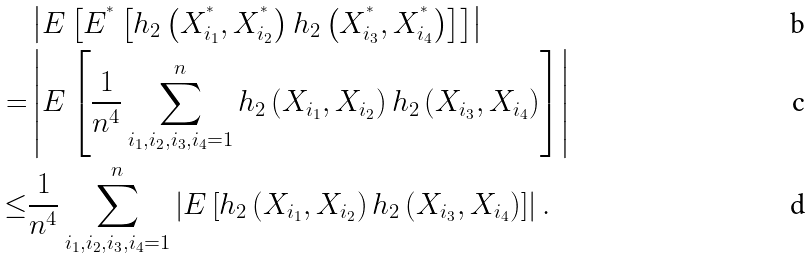<formula> <loc_0><loc_0><loc_500><loc_500>& \left | E \left [ E ^ { ^ { * } } \left [ h _ { 2 } \left ( X _ { i _ { 1 } } ^ { ^ { * } } , X _ { i _ { 2 } } ^ { ^ { * } } \right ) h _ { 2 } \left ( X _ { i _ { 3 } } ^ { ^ { * } } , X _ { i _ { 4 } } ^ { ^ { * } } \right ) \right ] \right ] \right | \\ = & \left | E \left [ \frac { 1 } { n ^ { 4 } } \sum _ { i _ { 1 } , i _ { 2 } , i _ { 3 } , i _ { 4 } = 1 } ^ { n } h _ { 2 } \left ( X _ { i _ { 1 } } , X _ { i _ { 2 } } \right ) h _ { 2 } \left ( X _ { i _ { 3 } } , X _ { i _ { 4 } } \right ) \right ] \right | \\ \leq & \frac { 1 } { n ^ { 4 } } \sum _ { i _ { 1 } , i _ { 2 } , i _ { 3 } , i _ { 4 } = 1 } ^ { n } \left | E \left [ h _ { 2 } \left ( X _ { i _ { 1 } } , X _ { i _ { 2 } } \right ) h _ { 2 } \left ( X _ { i _ { 3 } } , X _ { i _ { 4 } } \right ) \right ] \right | .</formula> 